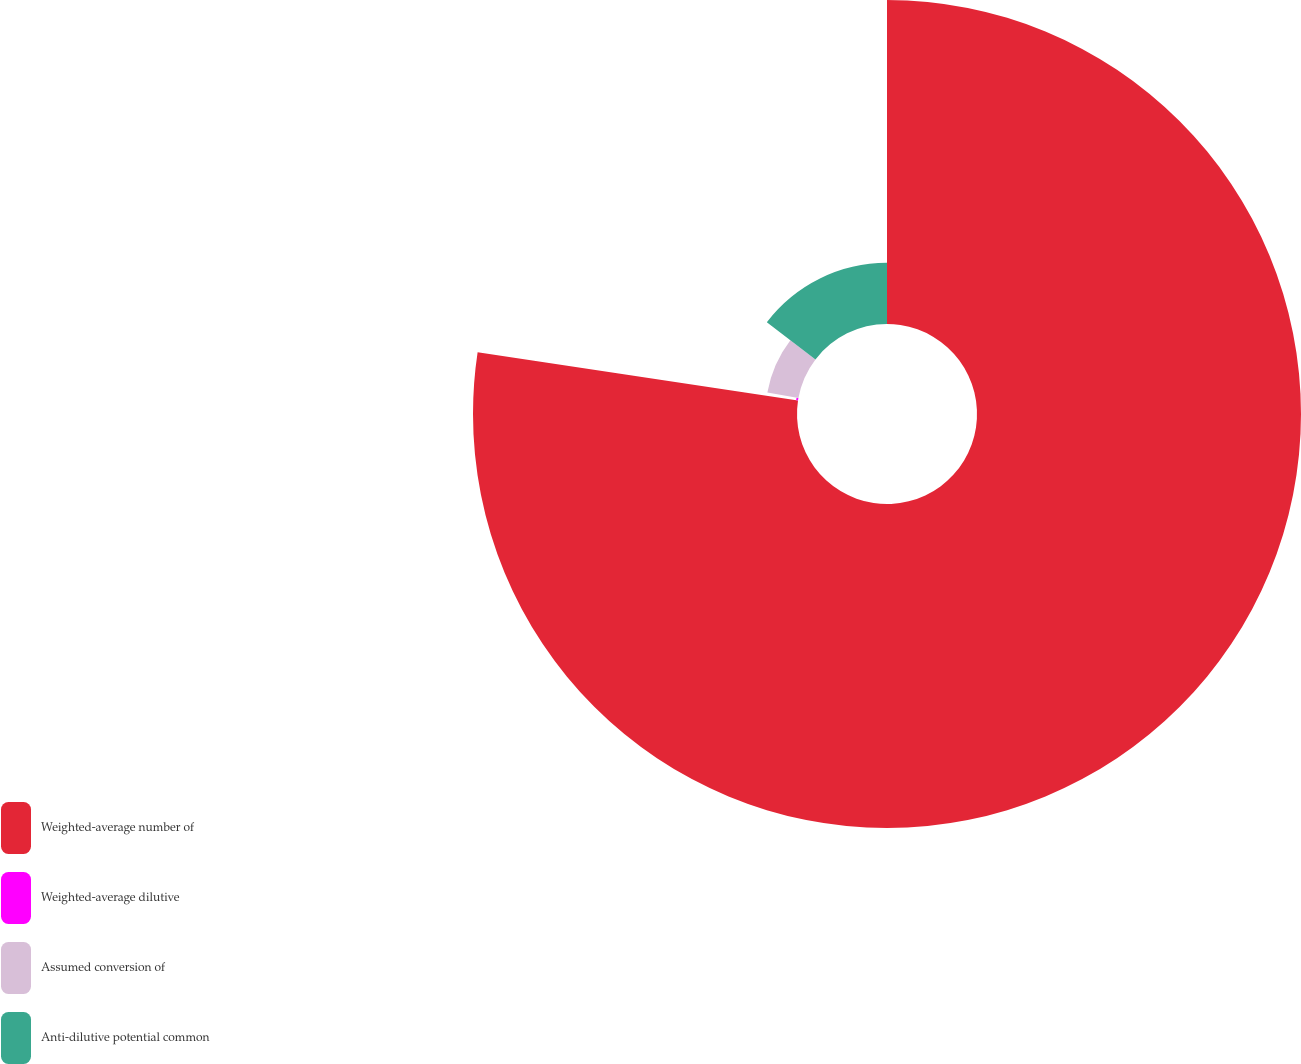Convert chart to OTSL. <chart><loc_0><loc_0><loc_500><loc_500><pie_chart><fcel>Weighted-average number of<fcel>Weighted-average dilutive<fcel>Assumed conversion of<fcel>Anti-dilutive potential common<nl><fcel>77.38%<fcel>0.46%<fcel>7.54%<fcel>14.62%<nl></chart> 